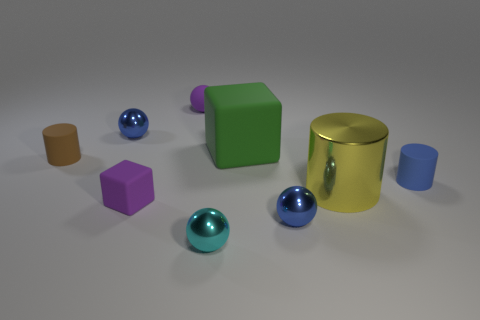What number of tiny shiny objects are left of the green rubber cube and in front of the tiny blue rubber thing?
Make the answer very short. 1. There is a brown matte thing; is it the same shape as the metallic thing behind the yellow metallic thing?
Provide a succinct answer. No. Are there more small blue cylinders that are to the right of the large yellow thing than big red shiny blocks?
Provide a short and direct response. Yes. Are there fewer metal spheres behind the big green object than rubber things?
Your response must be concise. Yes. How many tiny objects have the same color as the large cylinder?
Your response must be concise. 0. There is a small thing that is both left of the small cube and behind the big green thing; what is it made of?
Keep it short and to the point. Metal. There is a rubber thing in front of the tiny blue rubber object; is its color the same as the matte thing behind the large green block?
Provide a short and direct response. Yes. What number of purple objects are tiny rubber spheres or large metallic cylinders?
Offer a very short reply. 1. Is the number of small matte cylinders that are on the right side of the brown cylinder less than the number of objects on the left side of the large matte thing?
Your answer should be compact. Yes. Is there a brown rubber object that has the same size as the cyan shiny ball?
Provide a short and direct response. Yes. 